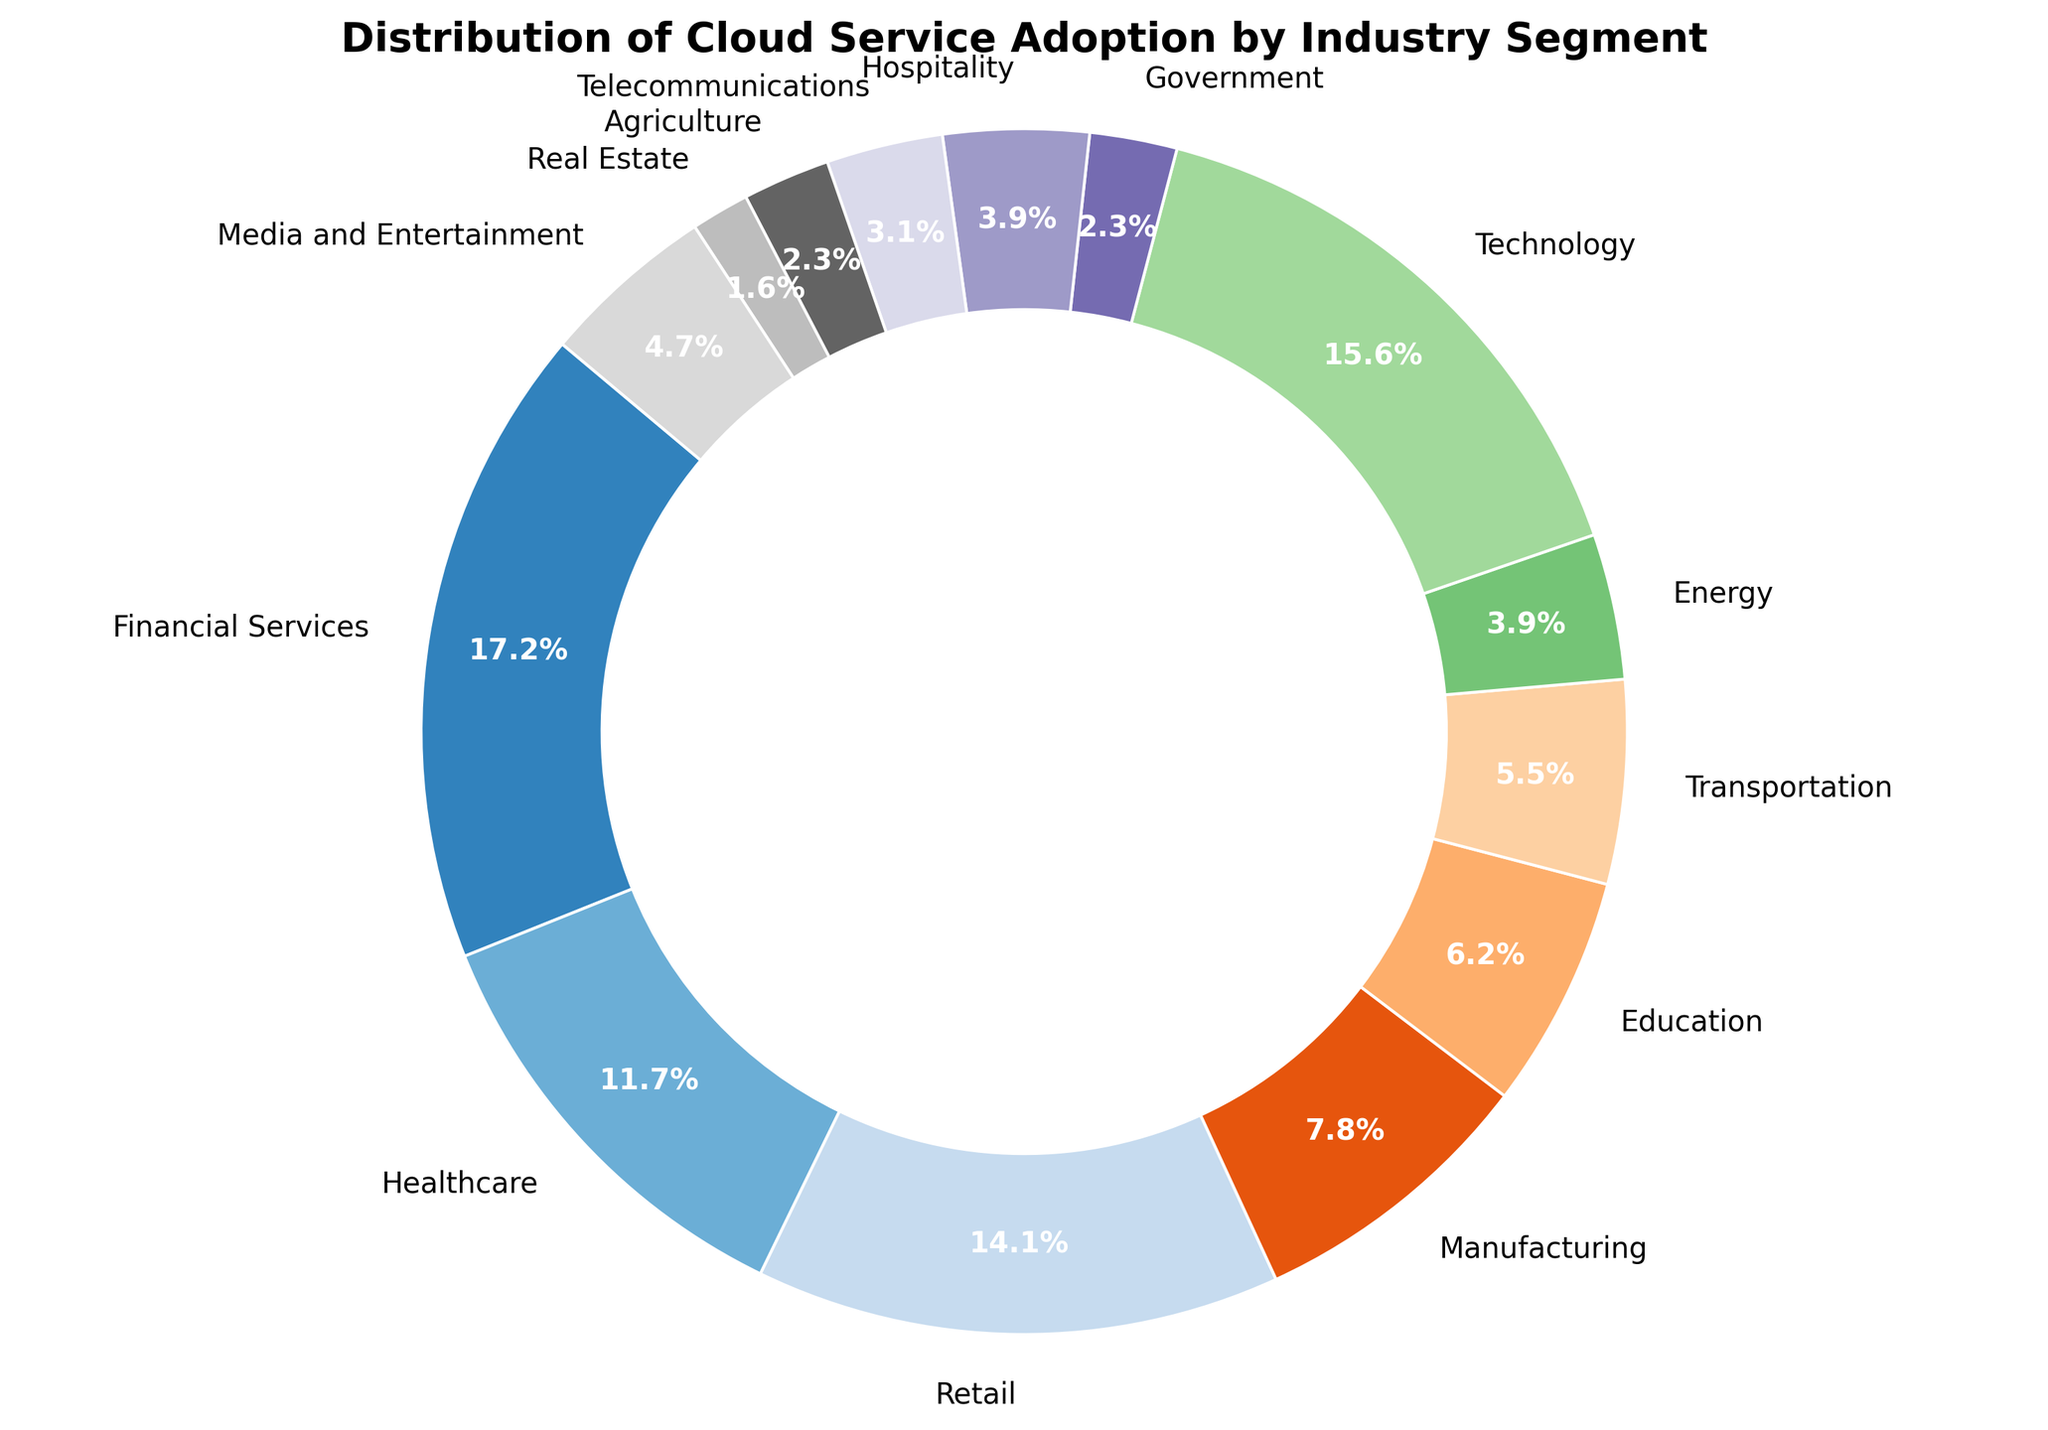What percentage of cloud service adoption is attributed to the Technology and Financial Services segments combined? To find the combined percentage, sum the percentages of Technology (20%) and Financial Services (22%). 20 + 22 = 42.
Answer: 42 Which industry segment has the highest cloud service adoption? By looking at the values, we see that Financial Services has the highest percentage of 22%.
Answer: Financial Services What is the difference in cloud service adoption between Retail and Manufacturing? The adoption percentages are Retail (18%) and Manufacturing (10%). The difference is 18 - 10 = 8.
Answer: 8 What is the total percentage of cloud service adoption for segments with less than 10% adoption? The segments are Manufacturing (10%), Education (8%), Transportation (7%), Energy (5%), Government (3%), Hospitality (5%), Telecommunications (4%), Agriculture (3%), Real Estate (2%), and Media and Entertainment (6%). The total is 10 + 8 + 7 + 5 + 3 + 5 + 4 + 3 + 2 + 6 = 53.
Answer: 53 Which segments have an adoption percentage greater than 15% but less than 25%? The segments that meet this criterion are Financial Services (22%), Healthcare (15%), Retail (18%), and Technology (20%).
Answer: Financial Services, Retail, Technology Which industry segment is depicted in blue in the ring chart? Locate the wedge colored blue in the chart and match it with the label.
Answer: Media and Entertainment What is the average percentage of cloud service adoption for Education, Transportation, and Energy? The percentages are Education (8%), Transportation (7%), and Energy (5%). The average is (8 + 7 + 5) / 3 = 6.67.
Answer: 6.67 How much more adoption does Technology have compared to Agriculture? The percentage for Technology is 20%, and for Agriculture, it is 3%. The difference is 20 - 3 = 17.
Answer: 17 Which segment has the lowest cloud service adoption, and what is its percentage? Real Estate has the lowest adoption percentage of 2%.
Answer: Real Estate, 2 